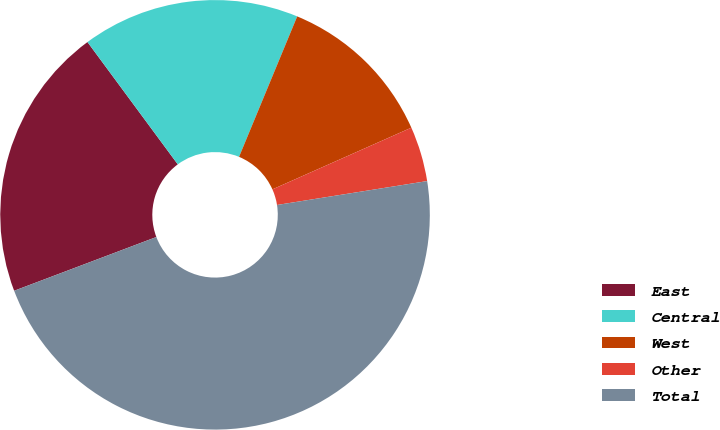Convert chart to OTSL. <chart><loc_0><loc_0><loc_500><loc_500><pie_chart><fcel>East<fcel>Central<fcel>West<fcel>Other<fcel>Total<nl><fcel>20.63%<fcel>16.37%<fcel>12.1%<fcel>4.14%<fcel>46.76%<nl></chart> 